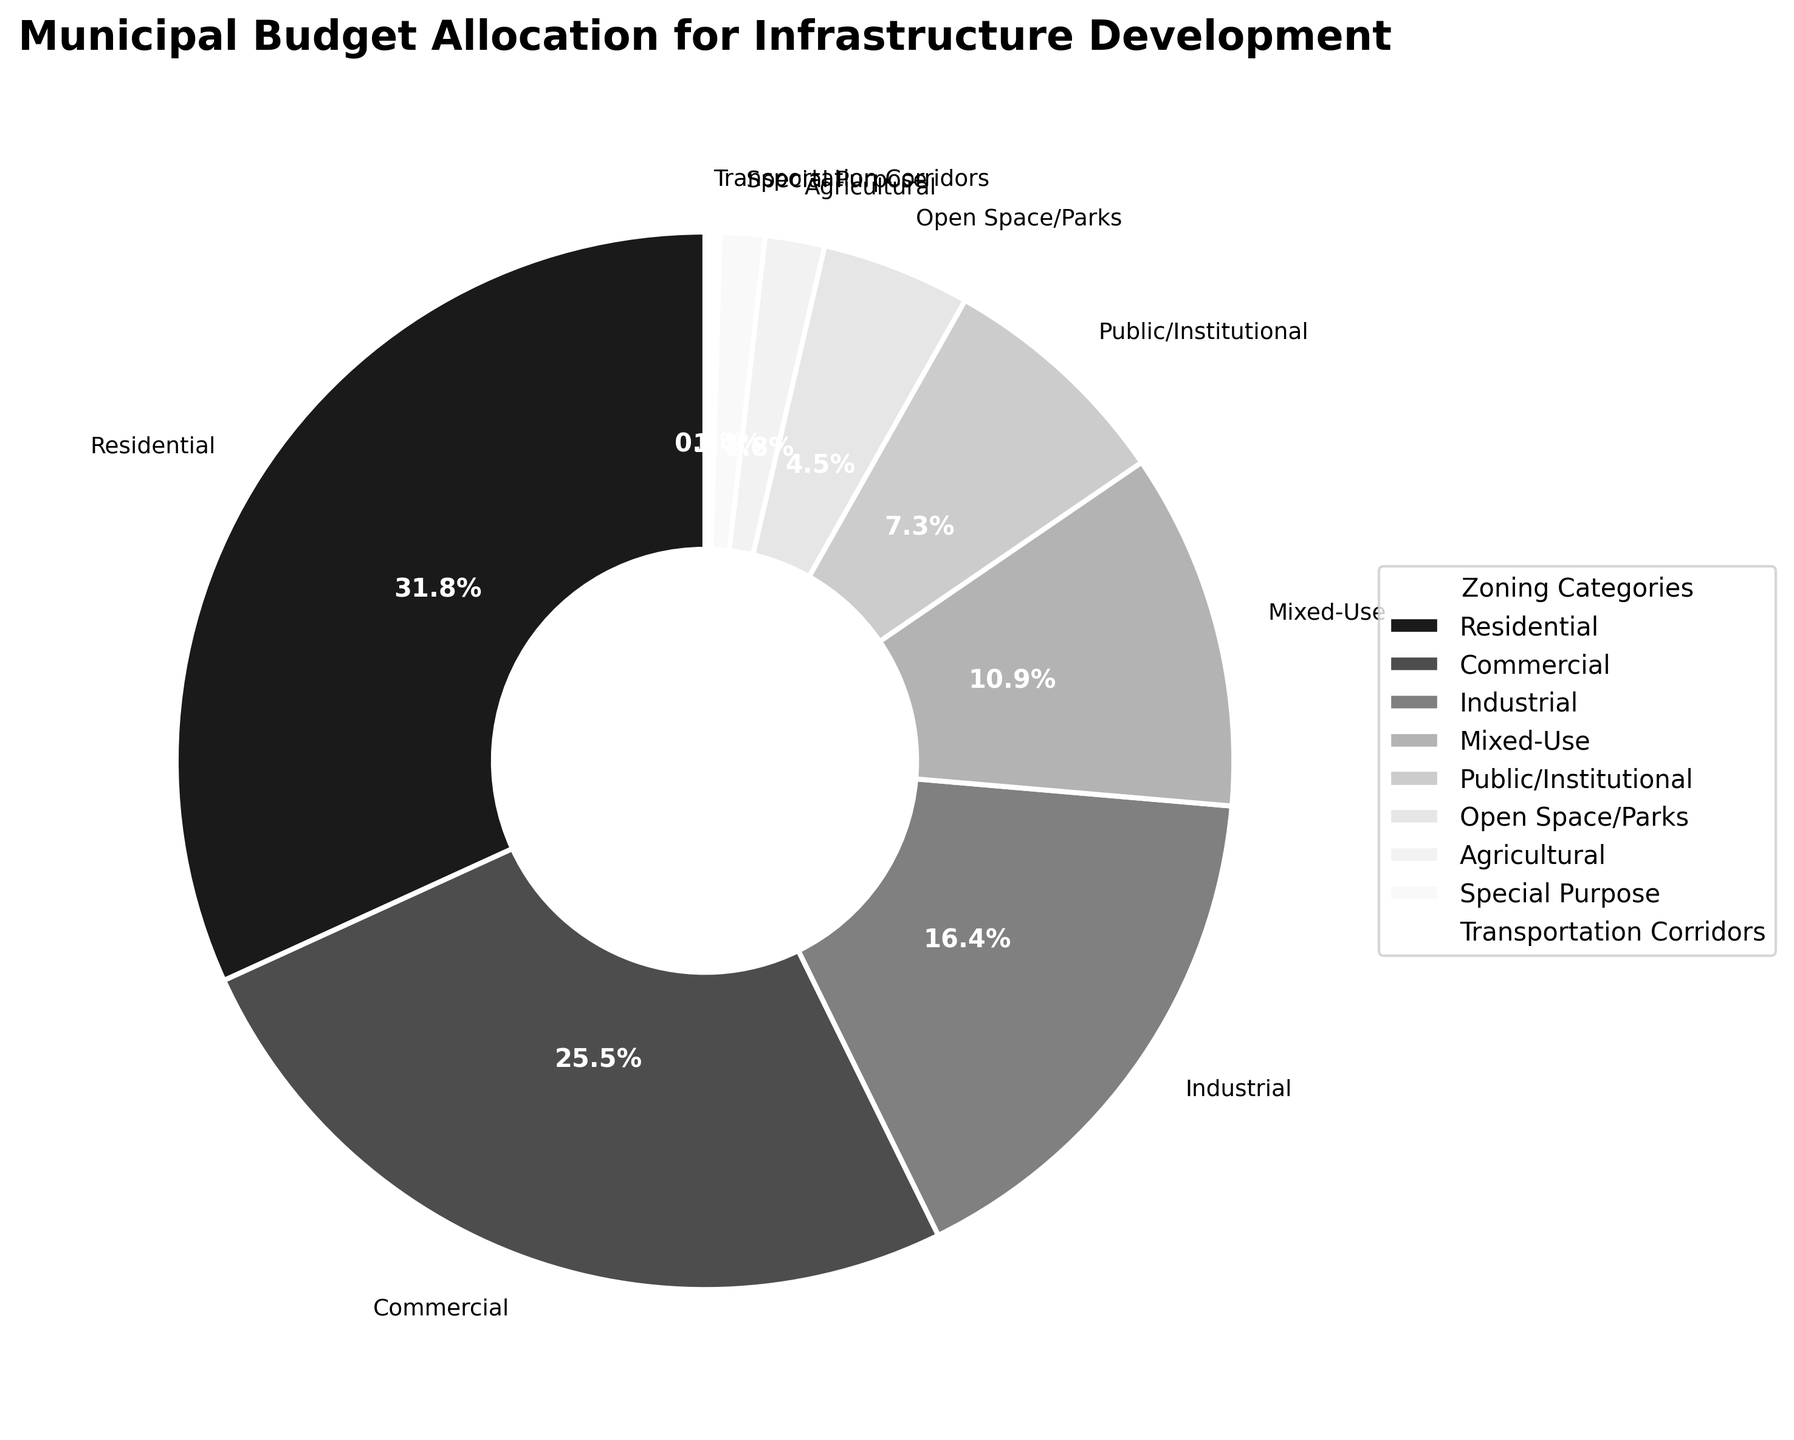Which two categories have the highest and lowest budget allocations? The highest budget allocation is observed in the Residential category with 35%, and the lowest budget allocation is observed in the Transportation Corridors category with 0.5%. These can be identified by looking at the largest and smallest slices of the pie chart, respectively.
Answer: Residential (35%) and Transportation Corridors (0.5%) What is the combined budget allocation for the Commercial and Industrial categories? The budget allocation for the Commercial category is 28%, and for the Industrial category is 18%. Adding them together, we get 28% + 18% = 46%.
Answer: 46% How does the budget allocation for Mixed-Use compare to that for Public/Institutional? The budget allocation for Mixed-Use is 12%, while for Public/Institutional it is 8%. Comparing these values, Mixed-Use has a higher budget allocation than Public/Institutional by 4% (12% - 8%).
Answer: Mixed-Use is 4% higher What percentage of the budget is allocated to categories with 10% or more? The categories allocating 10% or more are Residential (35%), Commercial (28%), Industrial (18%), and Mixed-Use (12%). Summing these values: 35% + 28% + 18% + 12% = 93%.
Answer: 93% Which zoning category has the least allocated budget that is still greater than 1%? Among the categories with more than 1% allocation, Agricultural has the least allocated budget with 2%. This is less than Open Space/Parks (5%) but more than Special Purpose (1.5%).
Answer: Agricultural (2%) What is the difference between the budget allocations for Open Space/Parks and Agricultural? The budget allocation for Open Space/Parks is 5%, and for Agricultural it is 2%. The difference between these two values is calculated as 5% - 2% = 3%.
Answer: 3% How much more budget is allocated to Residential than to Mixed-Use? The budget allocation for Residential is 35%, and for Mixed-Use it is 12%. The difference is calculated as 35% - 12% = 23%.
Answer: 23% What is the aggregate budget allocation for less than 10% categories? The categories with less than 10% allocation are Public/Institutional (8%), Open Space/Parks (5%), Agricultural (2%), Special Purpose (1.5%), and Transportation Corridors (0.5%). Summing these values: 8% + 5% + 2% + 1.5% + 0.5% = 17%.
Answer: 17% Which four categories together represent over half of the total budget allocation? The four categories with the largest budget allocations are Residential (35%), Commercial (28%), Industrial (18%), and Mixed-Use (12%). Adding these together: 35% + 28% + 18% + 12% = 93%. Together, these categories make up well over half of the total budget.
Answer: Residential, Commercial, Industrial, Mixed-Use What is the average budget allocation for the categories with more than 10% allocation? The categories with more than 10% allocation are Residential (35%), Commercial (28%), Industrial (18%), and Mixed-Use (12%). The average is calculated by (35% + 28% + 18% + 12%) / 4 = 93% / 4 = 23.25%.
Answer: 23.25% 